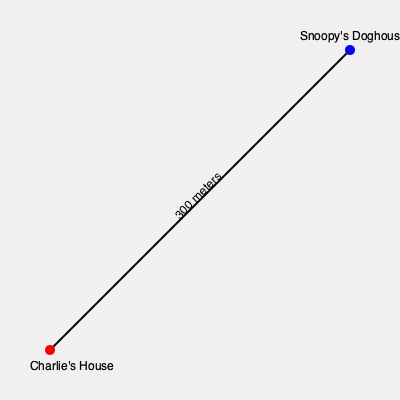In the Peanuts neighborhood, Charlie Brown's house and Snoopy's doghouse are located at opposite corners of a rectangular park. If the straight-line distance between them is 300 meters, and the park forms a perfect 45-45-90 triangle, what is the length of each side of the park? To solve this problem, we need to use the properties of a 45-45-90 triangle and the Pythagorean theorem:

1. In a 45-45-90 triangle, the two legs (sides adjacent to the right angle) are equal.
2. Let's call the length of each leg $x$.
3. The hypotenuse (longest side) of the triangle is given as 300 meters.
4. Using the Pythagorean theorem: $a^2 + b^2 = c^2$
5. In this case: $x^2 + x^2 = 300^2$
6. Simplify: $2x^2 = 300^2$
7. Solve for $x$:
   $x^2 = \frac{300^2}{2}$
   $x^2 = 45000$
   $x = \sqrt{45000}$
8. Simplify: $x = 150\sqrt{2}$ meters

Therefore, each side of the park (the distance from Charlie's house to the corner, and from the corner to Snoopy's doghouse) is $150\sqrt{2}$ meters.
Answer: $150\sqrt{2}$ meters 